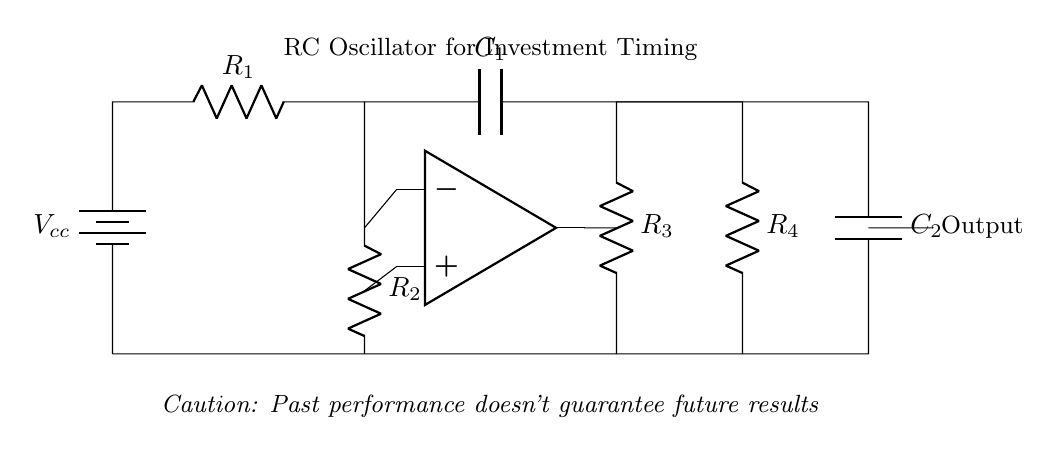What is the total resistance in the upper part of the circuit? The total resistance in the upper part consists of resistor R1 in series with resistor R2. R1 and R2 are directly connected, so the total resistance is R1 + R2.
Answer: R1 + R2 What is the role of capacitor C1 in the oscillator? Capacitor C1 is used to create phase shift in the circuit, which is essential for the oscillator's operation, allowing it to achieve the required feedback for oscillation.
Answer: Phase shift What type of oscillator is represented by this circuit? This circuit is a type of RC oscillator, specifically designed for generating oscillations or timing signals based on resistors and capacitors.
Answer: RC oscillator What happens if resistor R3 is removed from the circuit? If R3 is removed, the feedback network will be incomplete, preventing adequate phase shift for oscillation, leading to a failure to oscillate.
Answer: Failure to oscillate What is the frequency of oscillation primarily determined by? The frequency of oscillation in an RC oscillator is primarily determined by the values of resistors and capacitors used in the circuit (R1, R2, C1, and C2).
Answer: R and C values 